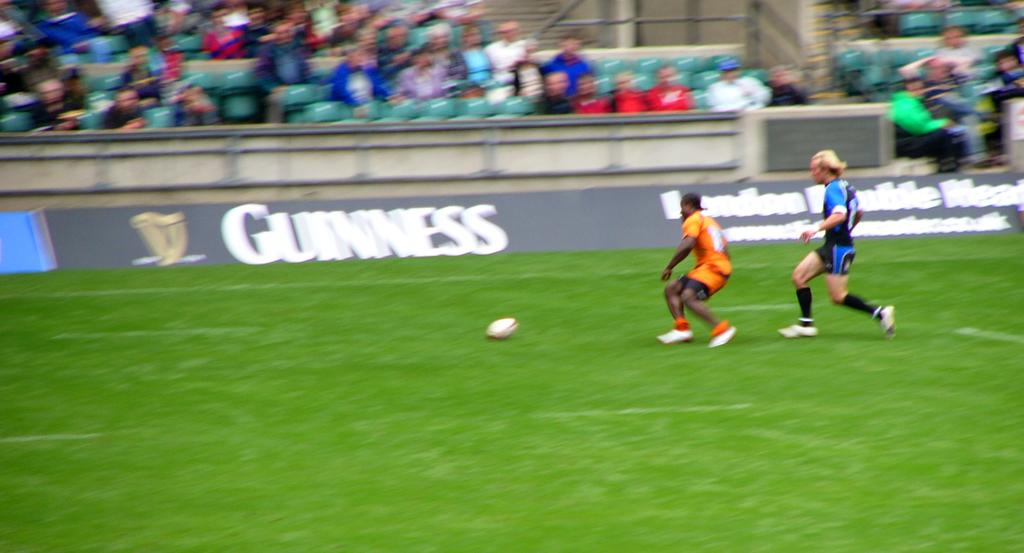What beverage is sponsoring this soccer match?
Make the answer very short. Guinness. 